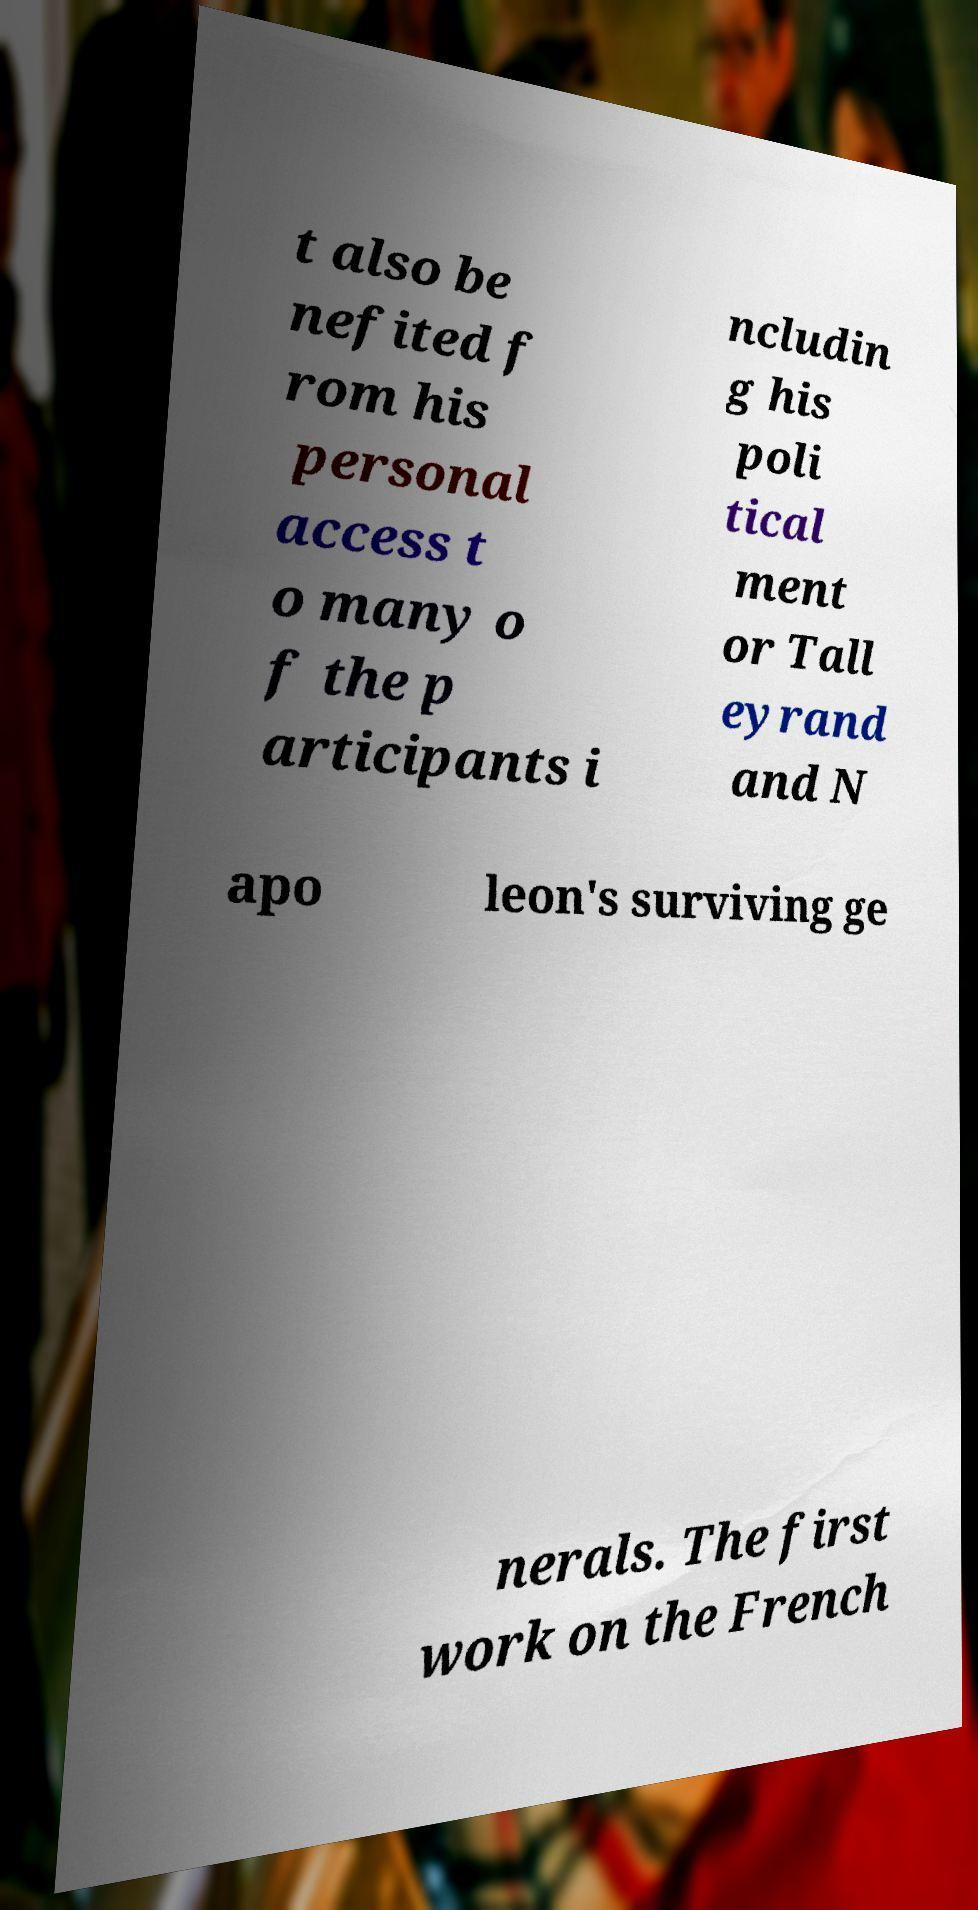There's text embedded in this image that I need extracted. Can you transcribe it verbatim? t also be nefited f rom his personal access t o many o f the p articipants i ncludin g his poli tical ment or Tall eyrand and N apo leon's surviving ge nerals. The first work on the French 